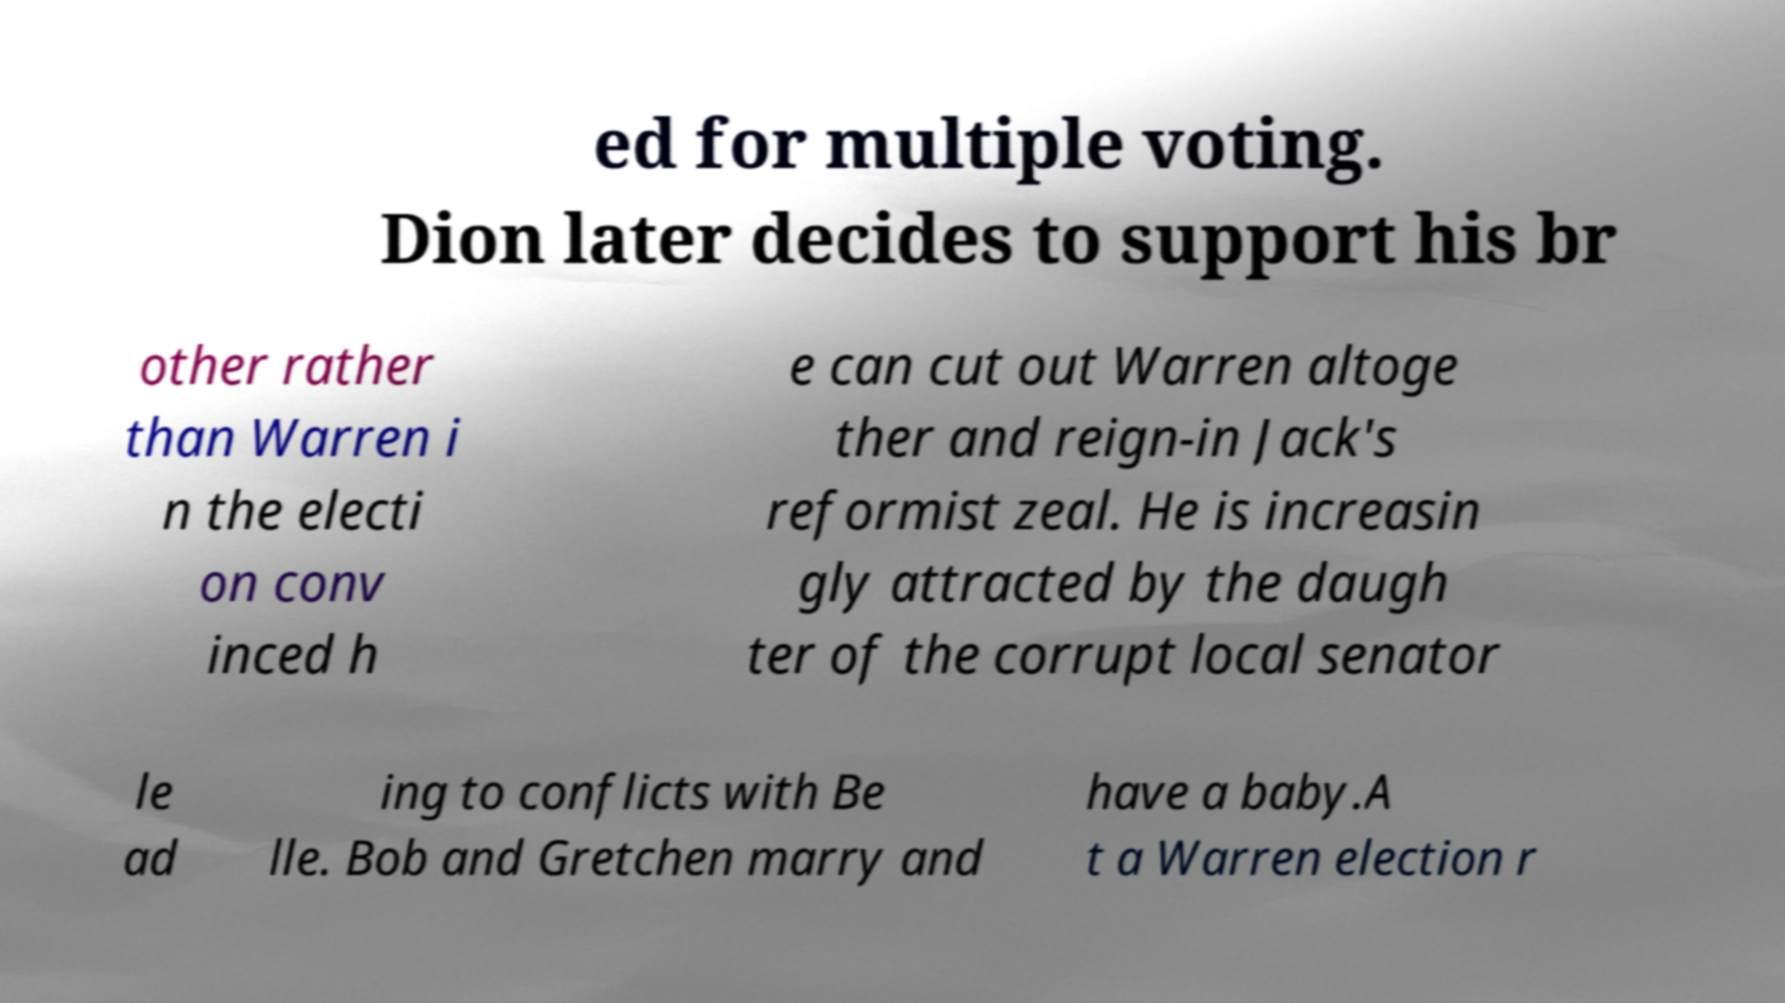Can you read and provide the text displayed in the image?This photo seems to have some interesting text. Can you extract and type it out for me? ed for multiple voting. Dion later decides to support his br other rather than Warren i n the electi on conv inced h e can cut out Warren altoge ther and reign-in Jack's reformist zeal. He is increasin gly attracted by the daugh ter of the corrupt local senator le ad ing to conflicts with Be lle. Bob and Gretchen marry and have a baby.A t a Warren election r 